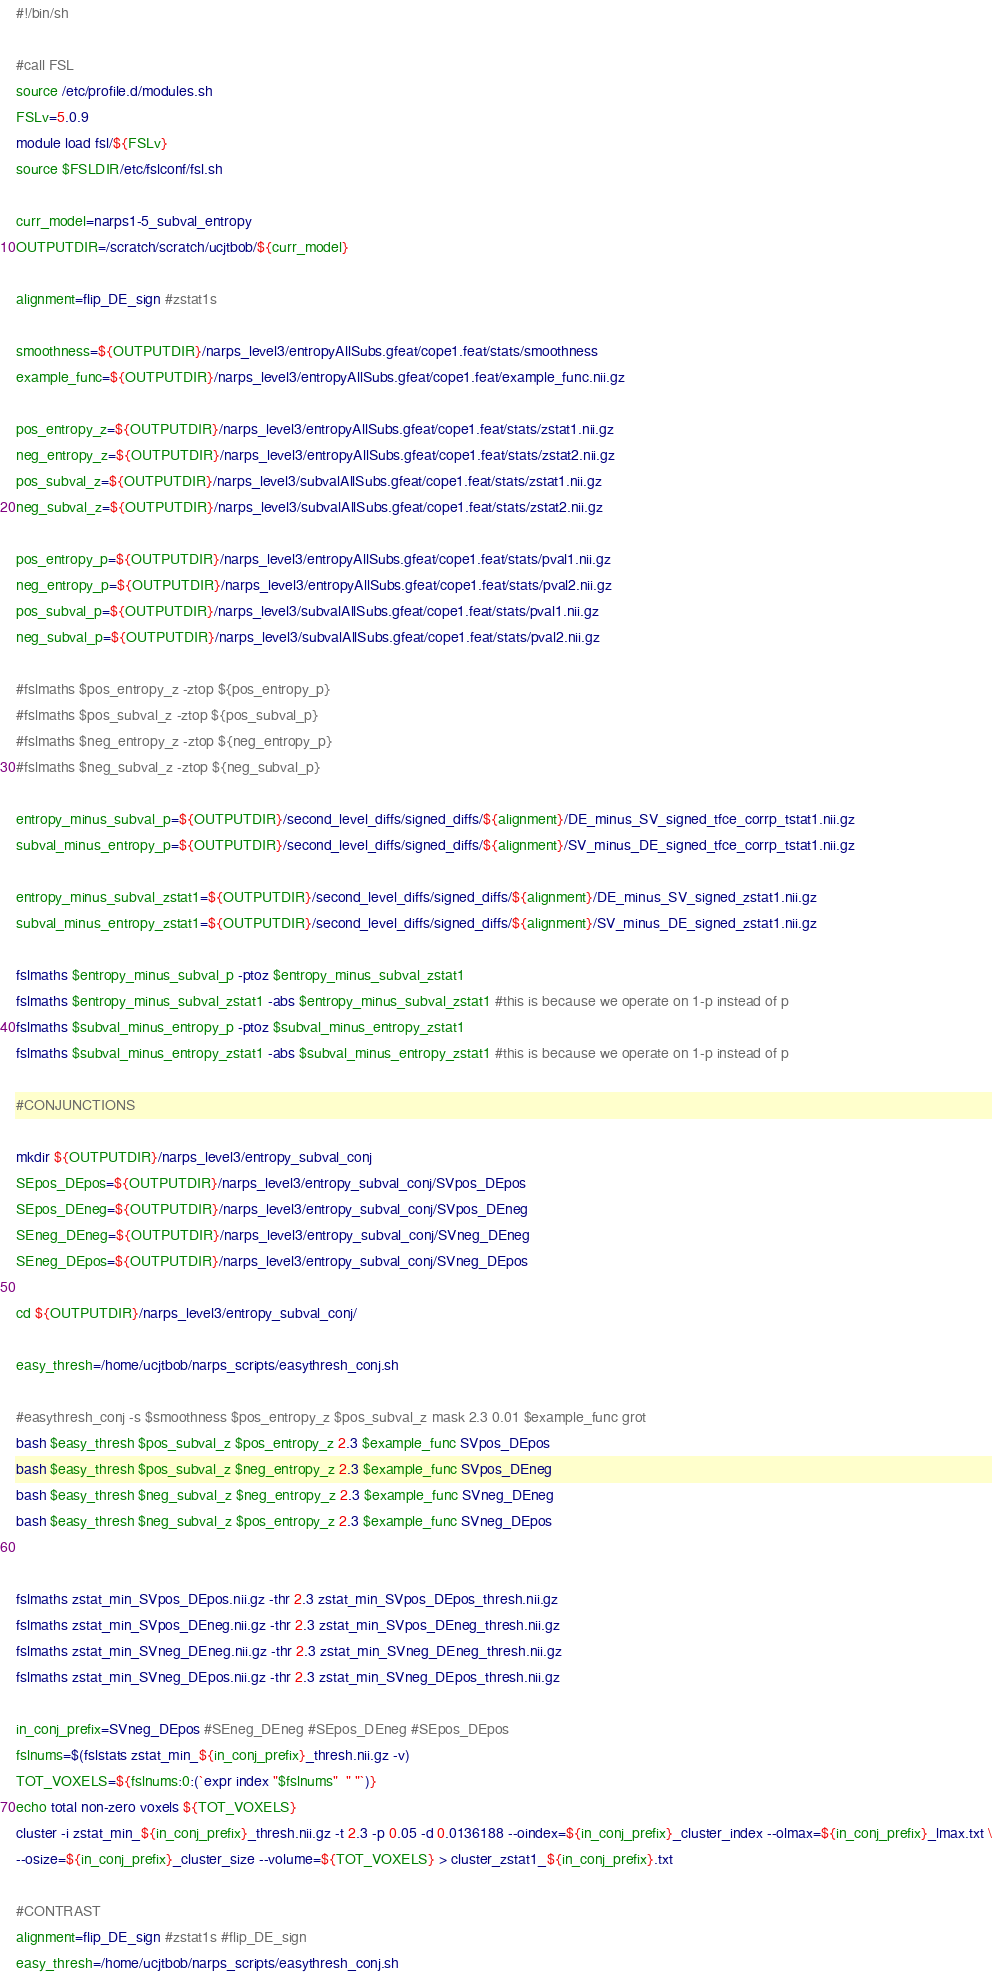Convert code to text. <code><loc_0><loc_0><loc_500><loc_500><_Bash_>#!/bin/sh

#call FSL
source /etc/profile.d/modules.sh
FSLv=5.0.9
module load fsl/${FSLv}
source $FSLDIR/etc/fslconf/fsl.sh

curr_model=narps1-5_subval_entropy
OUTPUTDIR=/scratch/scratch/ucjtbob/${curr_model}

alignment=flip_DE_sign #zstat1s

smoothness=${OUTPUTDIR}/narps_level3/entropyAllSubs.gfeat/cope1.feat/stats/smoothness
example_func=${OUTPUTDIR}/narps_level3/entropyAllSubs.gfeat/cope1.feat/example_func.nii.gz

pos_entropy_z=${OUTPUTDIR}/narps_level3/entropyAllSubs.gfeat/cope1.feat/stats/zstat1.nii.gz
neg_entropy_z=${OUTPUTDIR}/narps_level3/entropyAllSubs.gfeat/cope1.feat/stats/zstat2.nii.gz
pos_subval_z=${OUTPUTDIR}/narps_level3/subvalAllSubs.gfeat/cope1.feat/stats/zstat1.nii.gz
neg_subval_z=${OUTPUTDIR}/narps_level3/subvalAllSubs.gfeat/cope1.feat/stats/zstat2.nii.gz

pos_entropy_p=${OUTPUTDIR}/narps_level3/entropyAllSubs.gfeat/cope1.feat/stats/pval1.nii.gz
neg_entropy_p=${OUTPUTDIR}/narps_level3/entropyAllSubs.gfeat/cope1.feat/stats/pval2.nii.gz
pos_subval_p=${OUTPUTDIR}/narps_level3/subvalAllSubs.gfeat/cope1.feat/stats/pval1.nii.gz
neg_subval_p=${OUTPUTDIR}/narps_level3/subvalAllSubs.gfeat/cope1.feat/stats/pval2.nii.gz

#fslmaths $pos_entropy_z -ztop ${pos_entropy_p}
#fslmaths $pos_subval_z -ztop ${pos_subval_p}
#fslmaths $neg_entropy_z -ztop ${neg_entropy_p}
#fslmaths $neg_subval_z -ztop ${neg_subval_p}

entropy_minus_subval_p=${OUTPUTDIR}/second_level_diffs/signed_diffs/${alignment}/DE_minus_SV_signed_tfce_corrp_tstat1.nii.gz
subval_minus_entropy_p=${OUTPUTDIR}/second_level_diffs/signed_diffs/${alignment}/SV_minus_DE_signed_tfce_corrp_tstat1.nii.gz

entropy_minus_subval_zstat1=${OUTPUTDIR}/second_level_diffs/signed_diffs/${alignment}/DE_minus_SV_signed_zstat1.nii.gz
subval_minus_entropy_zstat1=${OUTPUTDIR}/second_level_diffs/signed_diffs/${alignment}/SV_minus_DE_signed_zstat1.nii.gz

fslmaths $entropy_minus_subval_p -ptoz $entropy_minus_subval_zstat1
fslmaths $entropy_minus_subval_zstat1 -abs $entropy_minus_subval_zstat1 #this is because we operate on 1-p instead of p
fslmaths $subval_minus_entropy_p -ptoz $subval_minus_entropy_zstat1
fslmaths $subval_minus_entropy_zstat1 -abs $subval_minus_entropy_zstat1 #this is because we operate on 1-p instead of p

#CONJUNCTIONS

mkdir ${OUTPUTDIR}/narps_level3/entropy_subval_conj
SEpos_DEpos=${OUTPUTDIR}/narps_level3/entropy_subval_conj/SVpos_DEpos
SEpos_DEneg=${OUTPUTDIR}/narps_level3/entropy_subval_conj/SVpos_DEneg
SEneg_DEneg=${OUTPUTDIR}/narps_level3/entropy_subval_conj/SVneg_DEneg
SEneg_DEpos=${OUTPUTDIR}/narps_level3/entropy_subval_conj/SVneg_DEpos

cd ${OUTPUTDIR}/narps_level3/entropy_subval_conj/

easy_thresh=/home/ucjtbob/narps_scripts/easythresh_conj.sh

#easythresh_conj -s $smoothness $pos_entropy_z $pos_subval_z mask 2.3 0.01 $example_func grot
bash $easy_thresh $pos_subval_z $pos_entropy_z 2.3 $example_func SVpos_DEpos
bash $easy_thresh $pos_subval_z $neg_entropy_z 2.3 $example_func SVpos_DEneg
bash $easy_thresh $neg_subval_z $neg_entropy_z 2.3 $example_func SVneg_DEneg
bash $easy_thresh $neg_subval_z $pos_entropy_z 2.3 $example_func SVneg_DEpos


fslmaths zstat_min_SVpos_DEpos.nii.gz -thr 2.3 zstat_min_SVpos_DEpos_thresh.nii.gz
fslmaths zstat_min_SVpos_DEneg.nii.gz -thr 2.3 zstat_min_SVpos_DEneg_thresh.nii.gz
fslmaths zstat_min_SVneg_DEneg.nii.gz -thr 2.3 zstat_min_SVneg_DEneg_thresh.nii.gz
fslmaths zstat_min_SVneg_DEpos.nii.gz -thr 2.3 zstat_min_SVneg_DEpos_thresh.nii.gz

in_conj_prefix=SVneg_DEpos #SEneg_DEneg #SEpos_DEneg #SEpos_DEpos
fslnums=$(fslstats zstat_min_${in_conj_prefix}_thresh.nii.gz -v)
TOT_VOXELS=${fslnums:0:(`expr index "$fslnums"  " "`)}
echo total non-zero voxels ${TOT_VOXELS}
cluster -i zstat_min_${in_conj_prefix}_thresh.nii.gz -t 2.3 -p 0.05 -d 0.0136188 --oindex=${in_conj_prefix}_cluster_index --olmax=${in_conj_prefix}_lmax.txt \
--osize=${in_conj_prefix}_cluster_size --volume=${TOT_VOXELS} > cluster_zstat1_${in_conj_prefix}.txt

#CONTRAST
alignment=flip_DE_sign #zstat1s #flip_DE_sign
easy_thresh=/home/ucjtbob/narps_scripts/easythresh_conj.sh</code> 